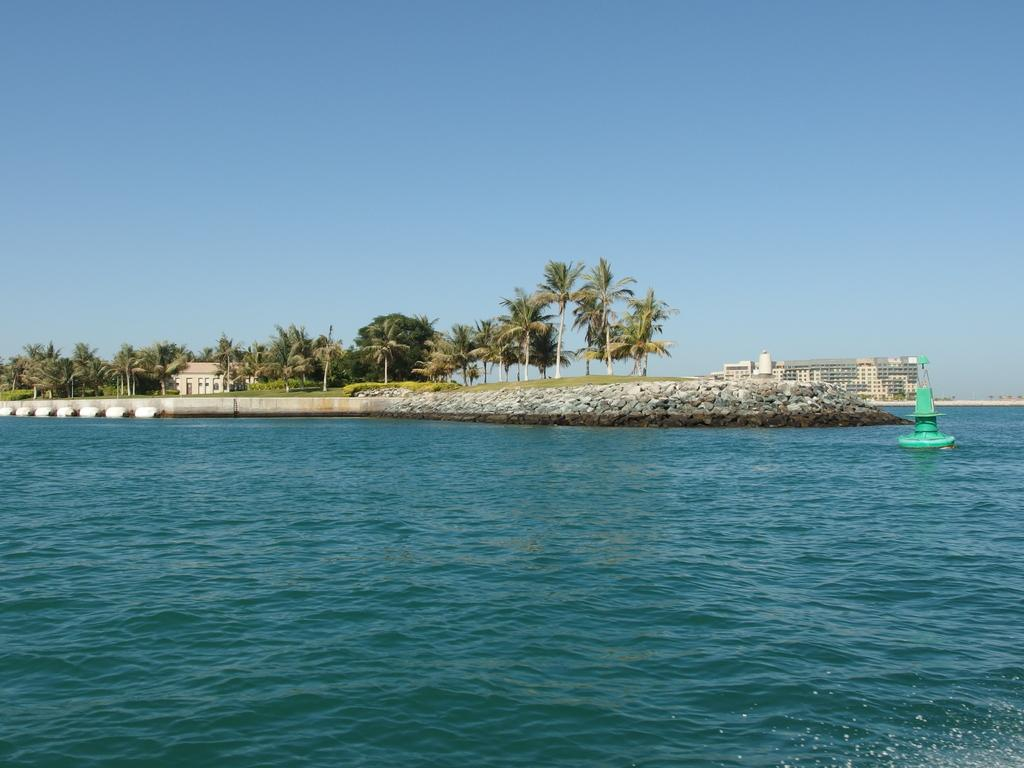What is the primary element in the image? There is water in the image. What can be found in the water? There is a green color thing in the water. What type of structure is present in the image? There is a rock wall in the image. What can be seen in the background of the image? There are trees, buildings, and the sky visible in the background of the image. What type of quince is being used to sweeten the water in the image? There is no quince present in the image, and the water does not appear to be sweetened. How many pictures are hanging on the rock wall in the image? There are no pictures hanging on the rock wall in the image; it is a natural rock formation. 